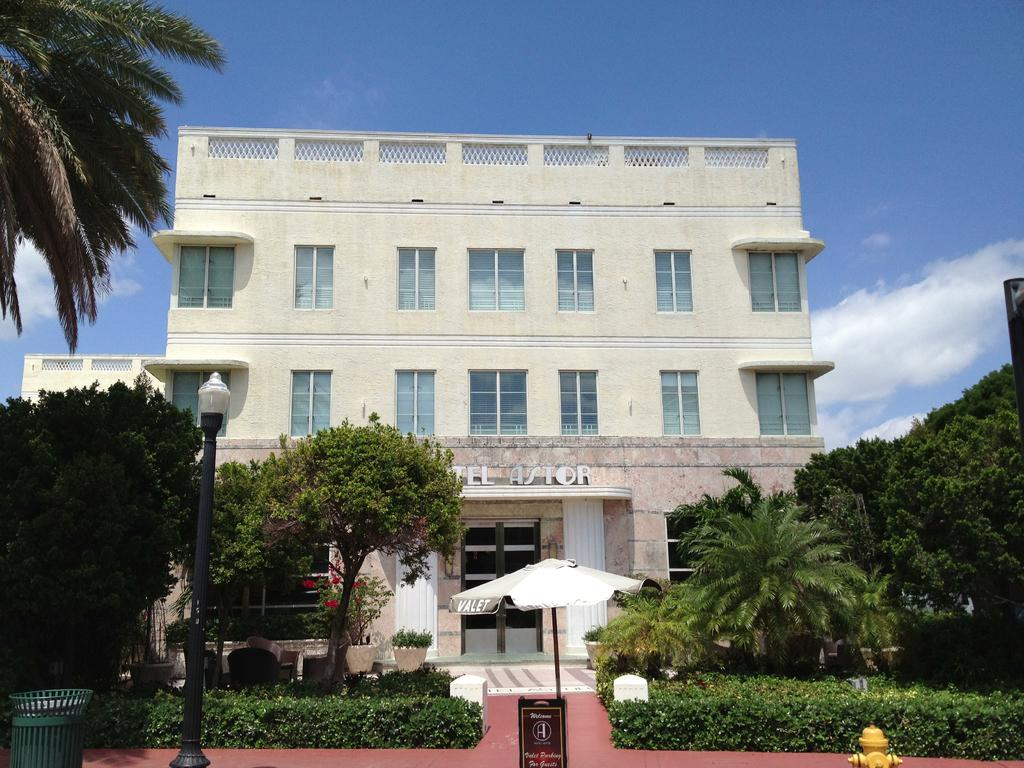<image>
Describe the image concisely. A white building with the word Astor on it and umbrella in front 